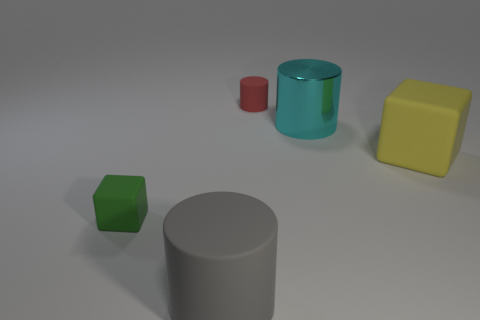Is there any other thing that has the same material as the big cyan cylinder?
Your answer should be very brief. No. Are there any red rubber cylinders behind the tiny red rubber thing?
Your response must be concise. No. Are there an equal number of big cylinders that are in front of the large cyan metal object and tiny cyan shiny objects?
Offer a very short reply. No. What size is the green matte thing that is the same shape as the yellow matte thing?
Your answer should be compact. Small. Do the small red thing and the thing on the left side of the large matte cylinder have the same shape?
Ensure brevity in your answer.  No. There is a matte cylinder that is in front of the large matte thing on the right side of the large gray matte thing; what is its size?
Keep it short and to the point. Large. Are there an equal number of big objects in front of the yellow rubber object and large blocks that are in front of the large gray matte thing?
Your response must be concise. No. There is a large object that is the same shape as the small green rubber thing; what color is it?
Provide a succinct answer. Yellow. What number of other large blocks are the same color as the big matte cube?
Offer a terse response. 0. There is a small object in front of the large yellow object; does it have the same shape as the big gray thing?
Keep it short and to the point. No. 